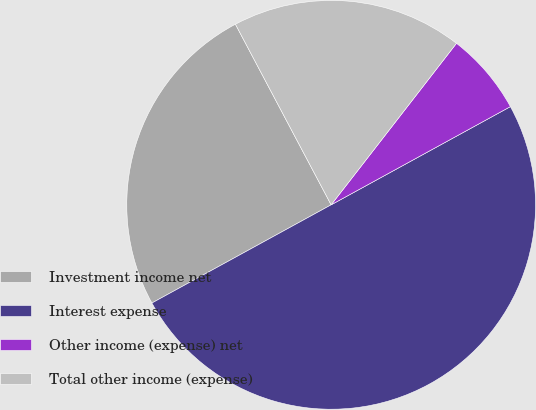<chart> <loc_0><loc_0><loc_500><loc_500><pie_chart><fcel>Investment income net<fcel>Interest expense<fcel>Other income (expense) net<fcel>Total other income (expense)<nl><fcel>25.22%<fcel>50.0%<fcel>6.52%<fcel>18.26%<nl></chart> 